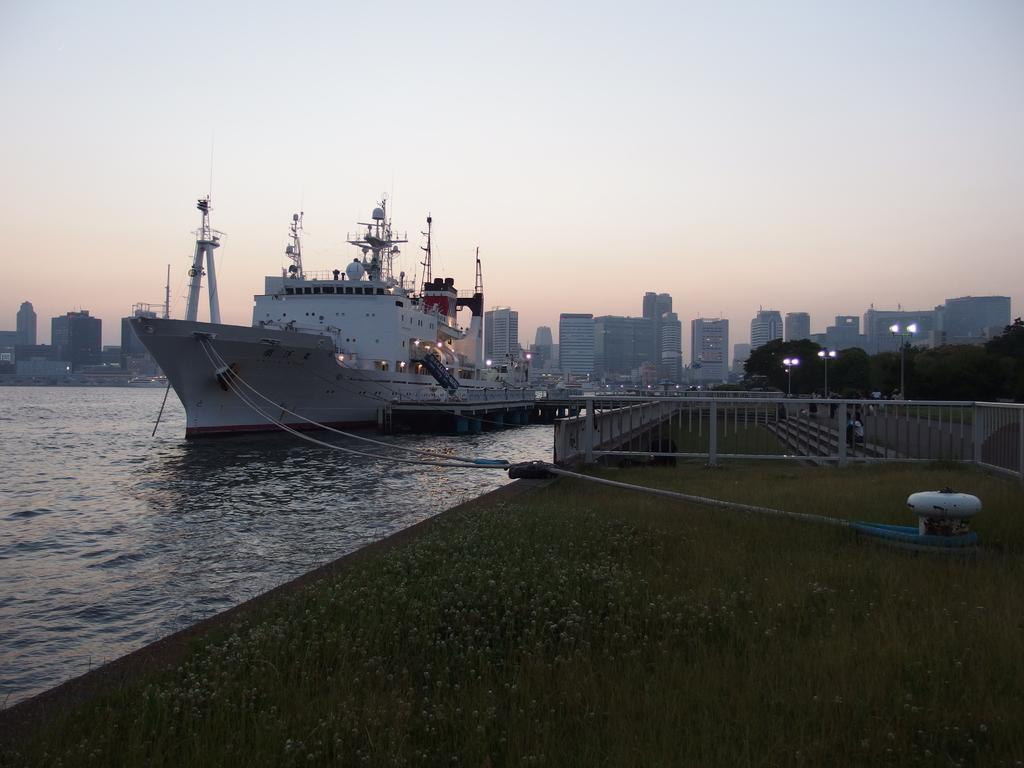How would you summarize this image in a sentence or two? In this picture, we can see a ship on the water and the ship is tied with ropes and on the path there is a fence, poles with lights, trees. Behind the ship there are buildings and sky. 